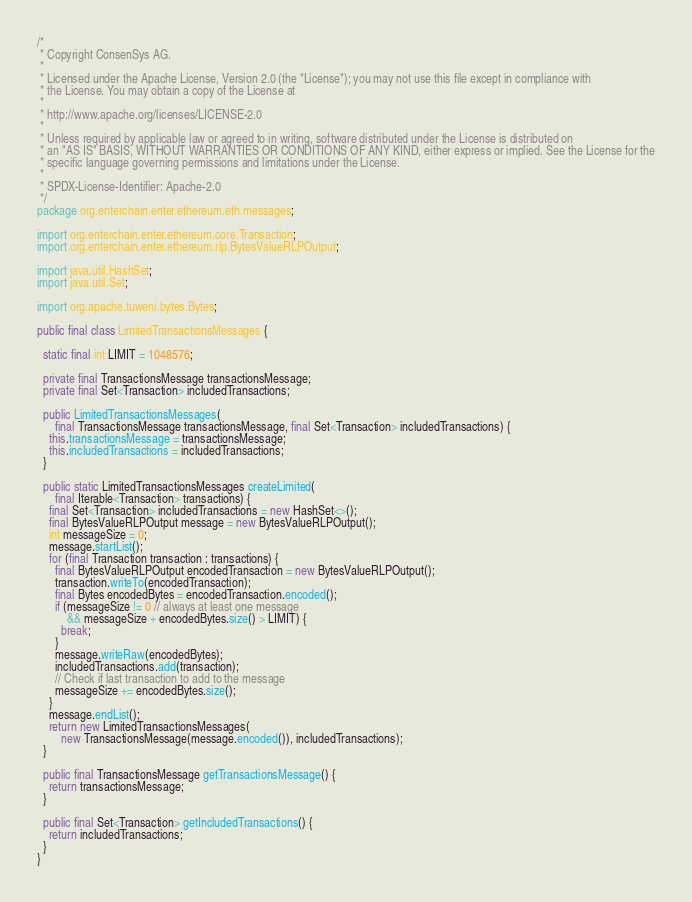<code> <loc_0><loc_0><loc_500><loc_500><_Java_>/*
 * Copyright ConsenSys AG.
 *
 * Licensed under the Apache License, Version 2.0 (the "License"); you may not use this file except in compliance with
 * the License. You may obtain a copy of the License at
 *
 * http://www.apache.org/licenses/LICENSE-2.0
 *
 * Unless required by applicable law or agreed to in writing, software distributed under the License is distributed on
 * an "AS IS" BASIS, WITHOUT WARRANTIES OR CONDITIONS OF ANY KIND, either express or implied. See the License for the
 * specific language governing permissions and limitations under the License.
 *
 * SPDX-License-Identifier: Apache-2.0
 */
package org.enterchain.enter.ethereum.eth.messages;

import org.enterchain.enter.ethereum.core.Transaction;
import org.enterchain.enter.ethereum.rlp.BytesValueRLPOutput;

import java.util.HashSet;
import java.util.Set;

import org.apache.tuweni.bytes.Bytes;

public final class LimitedTransactionsMessages {

  static final int LIMIT = 1048576;

  private final TransactionsMessage transactionsMessage;
  private final Set<Transaction> includedTransactions;

  public LimitedTransactionsMessages(
      final TransactionsMessage transactionsMessage, final Set<Transaction> includedTransactions) {
    this.transactionsMessage = transactionsMessage;
    this.includedTransactions = includedTransactions;
  }

  public static LimitedTransactionsMessages createLimited(
      final Iterable<Transaction> transactions) {
    final Set<Transaction> includedTransactions = new HashSet<>();
    final BytesValueRLPOutput message = new BytesValueRLPOutput();
    int messageSize = 0;
    message.startList();
    for (final Transaction transaction : transactions) {
      final BytesValueRLPOutput encodedTransaction = new BytesValueRLPOutput();
      transaction.writeTo(encodedTransaction);
      final Bytes encodedBytes = encodedTransaction.encoded();
      if (messageSize != 0 // always at least one message
          && messageSize + encodedBytes.size() > LIMIT) {
        break;
      }
      message.writeRaw(encodedBytes);
      includedTransactions.add(transaction);
      // Check if last transaction to add to the message
      messageSize += encodedBytes.size();
    }
    message.endList();
    return new LimitedTransactionsMessages(
        new TransactionsMessage(message.encoded()), includedTransactions);
  }

  public final TransactionsMessage getTransactionsMessage() {
    return transactionsMessage;
  }

  public final Set<Transaction> getIncludedTransactions() {
    return includedTransactions;
  }
}
</code> 